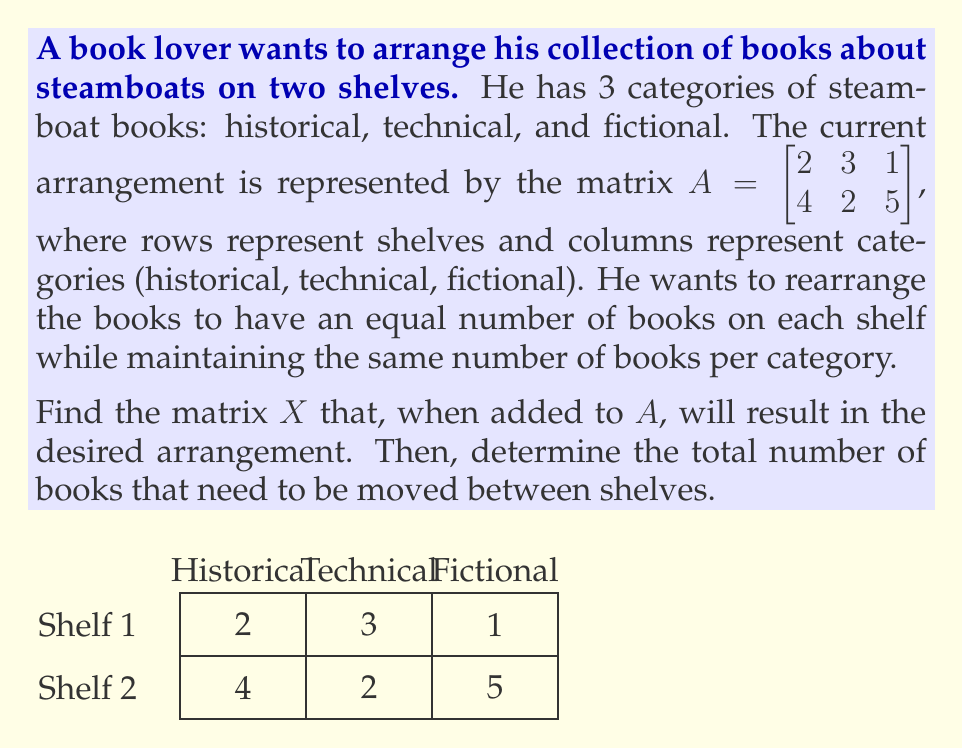Give your solution to this math problem. Let's approach this step-by-step:

1) First, we need to find the total number of books:
   $$\text{Total} = 2 + 3 + 1 + 4 + 2 + 5 = 17$$

2) For an equal number of books on each shelf, we need:
   $$\text{Books per shelf} = 17 \div 2 = 8.5$$
   Since we can't have half a book, this arrangement is impossible with the current number of books.

3) Let's define our matrix $X$:
   $$X = \begin{bmatrix} a & b & c \\ d & e & f \end{bmatrix}$$

4) For the new arrangement, we want:
   $$A + X = \begin{bmatrix} 3 & 3.5 & 3 \\ 3 & 3.5 & 3 \end{bmatrix}$$

5) This gives us the system of equations:
   $$\begin{cases}
   2 + a = 3 \\
   3 + b = 3.5 \\
   1 + c = 3 \\
   4 + d = 3 \\
   2 + e = 3.5 \\
   5 + f = 3
   \end{cases}$$

6) Solving this system:
   $$X = \begin{bmatrix} 1 & 0.5 & 2 \\ -1 & 1.5 & -2 \end{bmatrix}$$

7) To find the total number of books moved, we sum the absolute values of the elements in $X$:
   $$\text{Books moved} = |1| + |0.5| + |2| + |-1| + |1.5| + |-2| = 8$$

However, since we can't move half a book, this exact arrangement is not possible. The closest practical solution would be:

$$X = \begin{bmatrix} 1 & 0 & 2 \\ -1 & 2 & -2 \end{bmatrix}$$

This results in a final arrangement of:

$$A + X = \begin{bmatrix} 3 & 3 & 3 \\ 3 & 4 & 3 \end{bmatrix}$$

The total number of books moved would be 8.
Answer: 8 books 